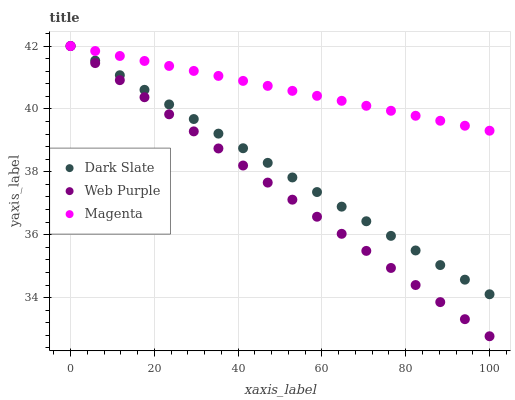Does Web Purple have the minimum area under the curve?
Answer yes or no. Yes. Does Magenta have the maximum area under the curve?
Answer yes or no. Yes. Does Magenta have the minimum area under the curve?
Answer yes or no. No. Does Web Purple have the maximum area under the curve?
Answer yes or no. No. Is Web Purple the smoothest?
Answer yes or no. Yes. Is Dark Slate the roughest?
Answer yes or no. Yes. Is Magenta the smoothest?
Answer yes or no. No. Is Magenta the roughest?
Answer yes or no. No. Does Web Purple have the lowest value?
Answer yes or no. Yes. Does Magenta have the lowest value?
Answer yes or no. No. Does Magenta have the highest value?
Answer yes or no. Yes. Does Dark Slate intersect Web Purple?
Answer yes or no. Yes. Is Dark Slate less than Web Purple?
Answer yes or no. No. Is Dark Slate greater than Web Purple?
Answer yes or no. No. 